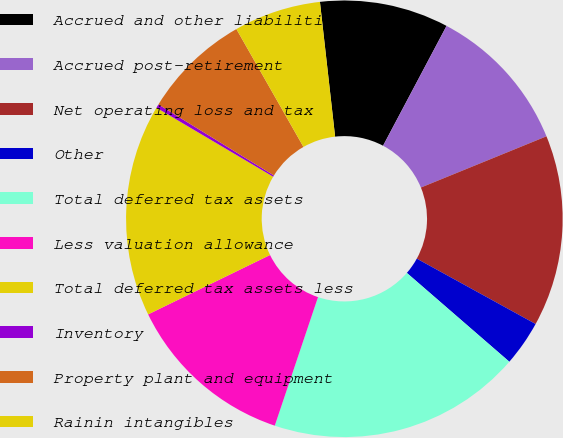<chart> <loc_0><loc_0><loc_500><loc_500><pie_chart><fcel>Accrued and other liabilities<fcel>Accrued post-retirement<fcel>Net operating loss and tax<fcel>Other<fcel>Total deferred tax assets<fcel>Less valuation allowance<fcel>Total deferred tax assets less<fcel>Inventory<fcel>Property plant and equipment<fcel>Rainin intangibles<nl><fcel>9.54%<fcel>11.08%<fcel>14.17%<fcel>3.36%<fcel>18.8%<fcel>12.62%<fcel>15.71%<fcel>0.28%<fcel>7.99%<fcel>6.45%<nl></chart> 